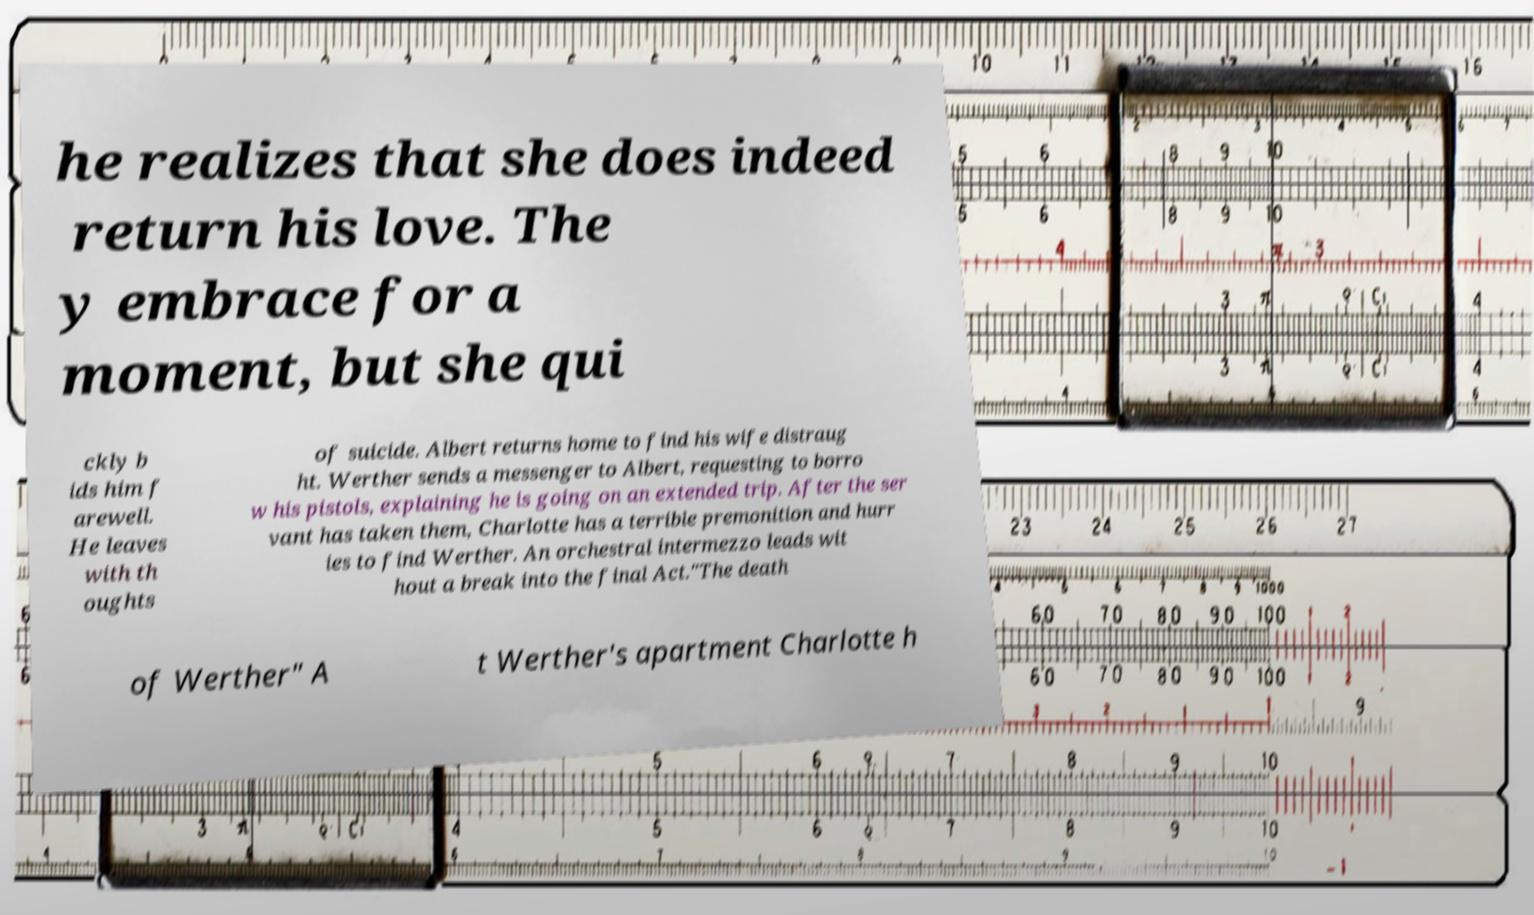There's text embedded in this image that I need extracted. Can you transcribe it verbatim? he realizes that she does indeed return his love. The y embrace for a moment, but she qui ckly b ids him f arewell. He leaves with th oughts of suicide. Albert returns home to find his wife distraug ht. Werther sends a messenger to Albert, requesting to borro w his pistols, explaining he is going on an extended trip. After the ser vant has taken them, Charlotte has a terrible premonition and hurr ies to find Werther. An orchestral intermezzo leads wit hout a break into the final Act."The death of Werther" A t Werther's apartment Charlotte h 